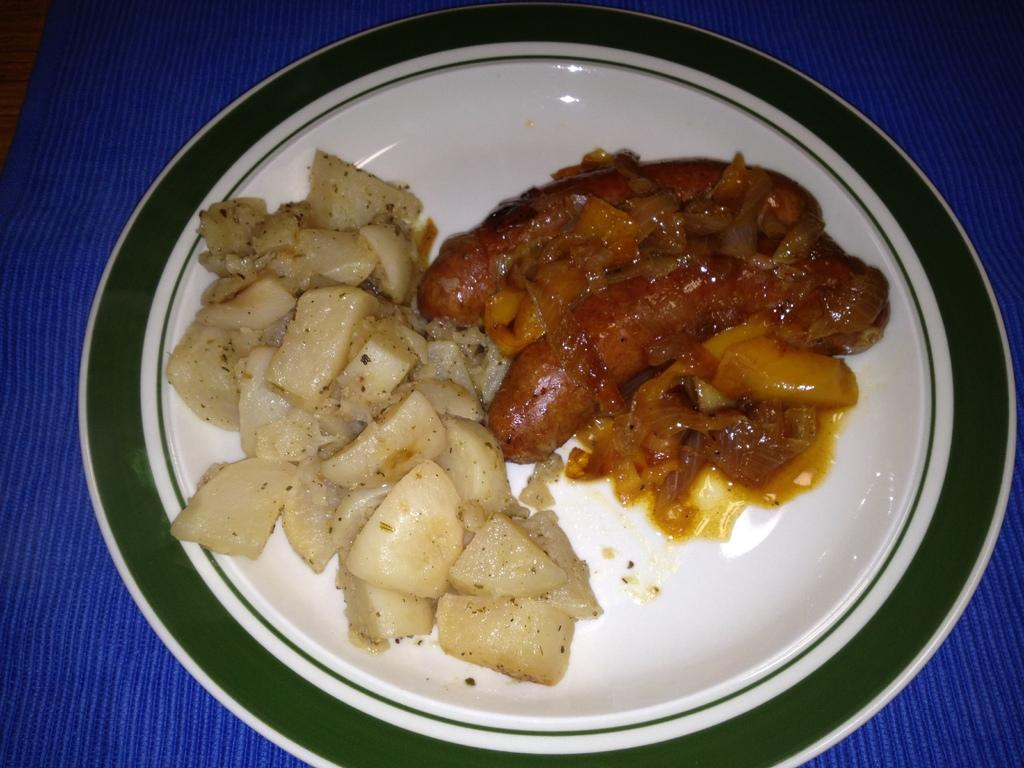What is present on the surface in the image? There is a plate in the image. What is the plate placed on? The plate is on a cloth. What can be found on the plate? There are food items in the plate. What invention is being demonstrated on the sidewalk in the image? There is no sidewalk or invention present in the image; it only features a plate with food items on a cloth. 